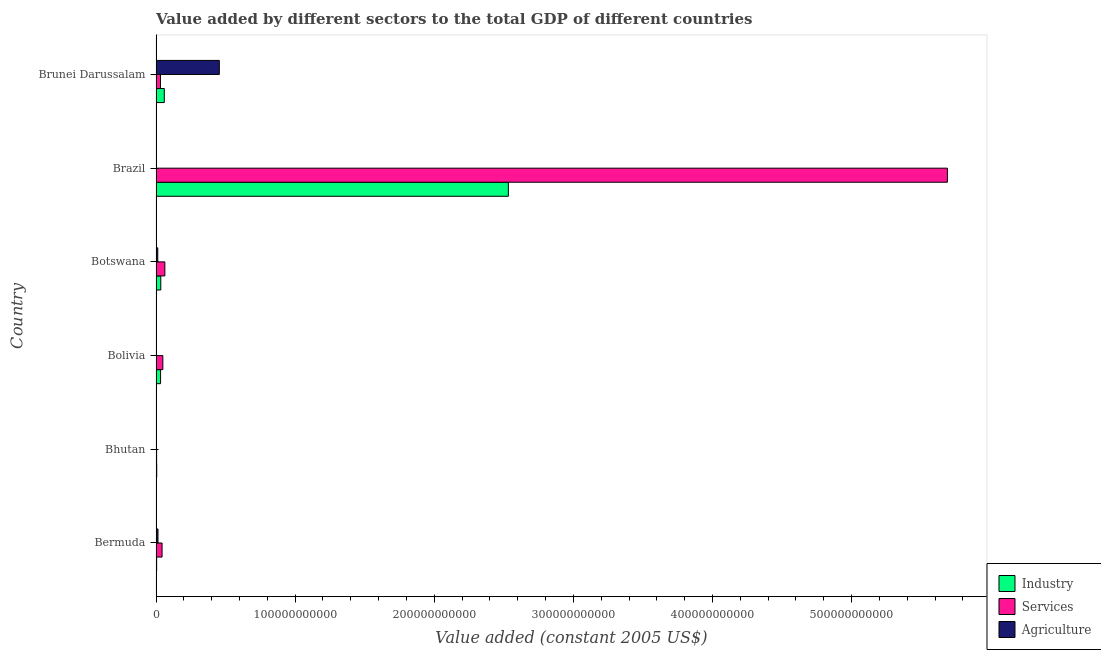Are the number of bars on each tick of the Y-axis equal?
Your answer should be compact. Yes. How many bars are there on the 6th tick from the top?
Offer a terse response. 3. What is the label of the 2nd group of bars from the top?
Your answer should be very brief. Brazil. What is the value added by agricultural sector in Bhutan?
Your answer should be compact. 4.42e+07. Across all countries, what is the maximum value added by industrial sector?
Your response must be concise. 2.53e+11. Across all countries, what is the minimum value added by agricultural sector?
Ensure brevity in your answer.  4.42e+07. In which country was the value added by agricultural sector maximum?
Your response must be concise. Brunei Darussalam. In which country was the value added by agricultural sector minimum?
Your answer should be very brief. Bhutan. What is the total value added by industrial sector in the graph?
Offer a very short reply. 2.67e+11. What is the difference between the value added by services in Bermuda and that in Brunei Darussalam?
Your response must be concise. 1.12e+09. What is the difference between the value added by industrial sector in Bermuda and the value added by agricultural sector in Brunei Darussalam?
Ensure brevity in your answer.  -4.51e+1. What is the average value added by agricultural sector per country?
Your answer should be compact. 8.11e+09. What is the difference between the value added by services and value added by industrial sector in Brunei Darussalam?
Give a very brief answer. -2.73e+09. What is the ratio of the value added by agricultural sector in Bhutan to that in Botswana?
Offer a very short reply. 0.04. What is the difference between the highest and the second highest value added by services?
Provide a succinct answer. 5.63e+11. What is the difference between the highest and the lowest value added by industrial sector?
Ensure brevity in your answer.  2.53e+11. Is the sum of the value added by services in Bhutan and Bolivia greater than the maximum value added by agricultural sector across all countries?
Keep it short and to the point. No. What does the 3rd bar from the top in Bhutan represents?
Provide a succinct answer. Industry. What does the 2nd bar from the bottom in Bolivia represents?
Keep it short and to the point. Services. Is it the case that in every country, the sum of the value added by industrial sector and value added by services is greater than the value added by agricultural sector?
Keep it short and to the point. No. How many countries are there in the graph?
Provide a short and direct response. 6. What is the difference between two consecutive major ticks on the X-axis?
Ensure brevity in your answer.  1.00e+11. Does the graph contain any zero values?
Give a very brief answer. No. Does the graph contain grids?
Ensure brevity in your answer.  No. How many legend labels are there?
Your answer should be very brief. 3. What is the title of the graph?
Make the answer very short. Value added by different sectors to the total GDP of different countries. Does "Domestic" appear as one of the legend labels in the graph?
Provide a succinct answer. No. What is the label or title of the X-axis?
Your answer should be compact. Value added (constant 2005 US$). What is the label or title of the Y-axis?
Your response must be concise. Country. What is the Value added (constant 2005 US$) of Industry in Bermuda?
Ensure brevity in your answer.  4.49e+08. What is the Value added (constant 2005 US$) in Services in Bermuda?
Your response must be concise. 4.35e+09. What is the Value added (constant 2005 US$) in Agriculture in Bermuda?
Your answer should be compact. 1.42e+09. What is the Value added (constant 2005 US$) of Industry in Bhutan?
Keep it short and to the point. 4.95e+08. What is the Value added (constant 2005 US$) in Services in Bhutan?
Your response must be concise. 4.24e+08. What is the Value added (constant 2005 US$) in Agriculture in Bhutan?
Offer a terse response. 4.42e+07. What is the Value added (constant 2005 US$) in Industry in Bolivia?
Give a very brief answer. 3.27e+09. What is the Value added (constant 2005 US$) in Services in Bolivia?
Give a very brief answer. 4.90e+09. What is the Value added (constant 2005 US$) in Agriculture in Bolivia?
Your response must be concise. 1.95e+08. What is the Value added (constant 2005 US$) in Industry in Botswana?
Your response must be concise. 3.42e+09. What is the Value added (constant 2005 US$) in Services in Botswana?
Provide a succinct answer. 6.35e+09. What is the Value added (constant 2005 US$) in Agriculture in Botswana?
Your answer should be compact. 1.24e+09. What is the Value added (constant 2005 US$) in Industry in Brazil?
Give a very brief answer. 2.53e+11. What is the Value added (constant 2005 US$) in Services in Brazil?
Your response must be concise. 5.69e+11. What is the Value added (constant 2005 US$) of Agriculture in Brazil?
Your answer should be compact. 2.51e+08. What is the Value added (constant 2005 US$) in Industry in Brunei Darussalam?
Your answer should be compact. 5.95e+09. What is the Value added (constant 2005 US$) of Services in Brunei Darussalam?
Keep it short and to the point. 3.22e+09. What is the Value added (constant 2005 US$) in Agriculture in Brunei Darussalam?
Your response must be concise. 4.55e+1. Across all countries, what is the maximum Value added (constant 2005 US$) in Industry?
Keep it short and to the point. 2.53e+11. Across all countries, what is the maximum Value added (constant 2005 US$) of Services?
Your answer should be compact. 5.69e+11. Across all countries, what is the maximum Value added (constant 2005 US$) of Agriculture?
Provide a succinct answer. 4.55e+1. Across all countries, what is the minimum Value added (constant 2005 US$) of Industry?
Your answer should be compact. 4.49e+08. Across all countries, what is the minimum Value added (constant 2005 US$) in Services?
Offer a very short reply. 4.24e+08. Across all countries, what is the minimum Value added (constant 2005 US$) of Agriculture?
Your answer should be very brief. 4.42e+07. What is the total Value added (constant 2005 US$) of Industry in the graph?
Offer a terse response. 2.67e+11. What is the total Value added (constant 2005 US$) in Services in the graph?
Give a very brief answer. 5.88e+11. What is the total Value added (constant 2005 US$) of Agriculture in the graph?
Your answer should be compact. 4.87e+1. What is the difference between the Value added (constant 2005 US$) in Industry in Bermuda and that in Bhutan?
Your answer should be very brief. -4.62e+07. What is the difference between the Value added (constant 2005 US$) of Services in Bermuda and that in Bhutan?
Keep it short and to the point. 3.92e+09. What is the difference between the Value added (constant 2005 US$) of Agriculture in Bermuda and that in Bhutan?
Give a very brief answer. 1.37e+09. What is the difference between the Value added (constant 2005 US$) in Industry in Bermuda and that in Bolivia?
Provide a short and direct response. -2.82e+09. What is the difference between the Value added (constant 2005 US$) in Services in Bermuda and that in Bolivia?
Make the answer very short. -5.52e+08. What is the difference between the Value added (constant 2005 US$) of Agriculture in Bermuda and that in Bolivia?
Ensure brevity in your answer.  1.22e+09. What is the difference between the Value added (constant 2005 US$) in Industry in Bermuda and that in Botswana?
Ensure brevity in your answer.  -2.97e+09. What is the difference between the Value added (constant 2005 US$) in Services in Bermuda and that in Botswana?
Give a very brief answer. -2.01e+09. What is the difference between the Value added (constant 2005 US$) in Agriculture in Bermuda and that in Botswana?
Your response must be concise. 1.72e+08. What is the difference between the Value added (constant 2005 US$) of Industry in Bermuda and that in Brazil?
Ensure brevity in your answer.  -2.53e+11. What is the difference between the Value added (constant 2005 US$) of Services in Bermuda and that in Brazil?
Your answer should be very brief. -5.65e+11. What is the difference between the Value added (constant 2005 US$) in Agriculture in Bermuda and that in Brazil?
Your response must be concise. 1.16e+09. What is the difference between the Value added (constant 2005 US$) in Industry in Bermuda and that in Brunei Darussalam?
Offer a terse response. -5.50e+09. What is the difference between the Value added (constant 2005 US$) of Services in Bermuda and that in Brunei Darussalam?
Ensure brevity in your answer.  1.12e+09. What is the difference between the Value added (constant 2005 US$) of Agriculture in Bermuda and that in Brunei Darussalam?
Make the answer very short. -4.41e+1. What is the difference between the Value added (constant 2005 US$) of Industry in Bhutan and that in Bolivia?
Your answer should be compact. -2.77e+09. What is the difference between the Value added (constant 2005 US$) of Services in Bhutan and that in Bolivia?
Offer a terse response. -4.47e+09. What is the difference between the Value added (constant 2005 US$) of Agriculture in Bhutan and that in Bolivia?
Offer a terse response. -1.51e+08. What is the difference between the Value added (constant 2005 US$) of Industry in Bhutan and that in Botswana?
Keep it short and to the point. -2.92e+09. What is the difference between the Value added (constant 2005 US$) in Services in Bhutan and that in Botswana?
Offer a very short reply. -5.93e+09. What is the difference between the Value added (constant 2005 US$) in Agriculture in Bhutan and that in Botswana?
Offer a very short reply. -1.20e+09. What is the difference between the Value added (constant 2005 US$) of Industry in Bhutan and that in Brazil?
Give a very brief answer. -2.53e+11. What is the difference between the Value added (constant 2005 US$) of Services in Bhutan and that in Brazil?
Provide a short and direct response. -5.68e+11. What is the difference between the Value added (constant 2005 US$) in Agriculture in Bhutan and that in Brazil?
Keep it short and to the point. -2.06e+08. What is the difference between the Value added (constant 2005 US$) in Industry in Bhutan and that in Brunei Darussalam?
Your answer should be compact. -5.45e+09. What is the difference between the Value added (constant 2005 US$) in Services in Bhutan and that in Brunei Darussalam?
Ensure brevity in your answer.  -2.80e+09. What is the difference between the Value added (constant 2005 US$) in Agriculture in Bhutan and that in Brunei Darussalam?
Offer a very short reply. -4.55e+1. What is the difference between the Value added (constant 2005 US$) in Industry in Bolivia and that in Botswana?
Provide a short and direct response. -1.52e+08. What is the difference between the Value added (constant 2005 US$) in Services in Bolivia and that in Botswana?
Give a very brief answer. -1.46e+09. What is the difference between the Value added (constant 2005 US$) in Agriculture in Bolivia and that in Botswana?
Your answer should be compact. -1.05e+09. What is the difference between the Value added (constant 2005 US$) in Industry in Bolivia and that in Brazil?
Your answer should be very brief. -2.50e+11. What is the difference between the Value added (constant 2005 US$) of Services in Bolivia and that in Brazil?
Make the answer very short. -5.64e+11. What is the difference between the Value added (constant 2005 US$) of Agriculture in Bolivia and that in Brazil?
Give a very brief answer. -5.51e+07. What is the difference between the Value added (constant 2005 US$) of Industry in Bolivia and that in Brunei Darussalam?
Make the answer very short. -2.68e+09. What is the difference between the Value added (constant 2005 US$) in Services in Bolivia and that in Brunei Darussalam?
Make the answer very short. 1.68e+09. What is the difference between the Value added (constant 2005 US$) of Agriculture in Bolivia and that in Brunei Darussalam?
Provide a succinct answer. -4.53e+1. What is the difference between the Value added (constant 2005 US$) in Industry in Botswana and that in Brazil?
Provide a succinct answer. -2.50e+11. What is the difference between the Value added (constant 2005 US$) of Services in Botswana and that in Brazil?
Your response must be concise. -5.63e+11. What is the difference between the Value added (constant 2005 US$) in Agriculture in Botswana and that in Brazil?
Offer a very short reply. 9.92e+08. What is the difference between the Value added (constant 2005 US$) of Industry in Botswana and that in Brunei Darussalam?
Offer a terse response. -2.53e+09. What is the difference between the Value added (constant 2005 US$) of Services in Botswana and that in Brunei Darussalam?
Your response must be concise. 3.13e+09. What is the difference between the Value added (constant 2005 US$) in Agriculture in Botswana and that in Brunei Darussalam?
Your response must be concise. -4.43e+1. What is the difference between the Value added (constant 2005 US$) of Industry in Brazil and that in Brunei Darussalam?
Keep it short and to the point. 2.47e+11. What is the difference between the Value added (constant 2005 US$) in Services in Brazil and that in Brunei Darussalam?
Your response must be concise. 5.66e+11. What is the difference between the Value added (constant 2005 US$) of Agriculture in Brazil and that in Brunei Darussalam?
Make the answer very short. -4.53e+1. What is the difference between the Value added (constant 2005 US$) of Industry in Bermuda and the Value added (constant 2005 US$) of Services in Bhutan?
Provide a succinct answer. 2.50e+07. What is the difference between the Value added (constant 2005 US$) in Industry in Bermuda and the Value added (constant 2005 US$) in Agriculture in Bhutan?
Provide a succinct answer. 4.05e+08. What is the difference between the Value added (constant 2005 US$) of Services in Bermuda and the Value added (constant 2005 US$) of Agriculture in Bhutan?
Keep it short and to the point. 4.30e+09. What is the difference between the Value added (constant 2005 US$) in Industry in Bermuda and the Value added (constant 2005 US$) in Services in Bolivia?
Ensure brevity in your answer.  -4.45e+09. What is the difference between the Value added (constant 2005 US$) of Industry in Bermuda and the Value added (constant 2005 US$) of Agriculture in Bolivia?
Offer a very short reply. 2.54e+08. What is the difference between the Value added (constant 2005 US$) of Services in Bermuda and the Value added (constant 2005 US$) of Agriculture in Bolivia?
Offer a very short reply. 4.15e+09. What is the difference between the Value added (constant 2005 US$) of Industry in Bermuda and the Value added (constant 2005 US$) of Services in Botswana?
Your answer should be compact. -5.90e+09. What is the difference between the Value added (constant 2005 US$) of Industry in Bermuda and the Value added (constant 2005 US$) of Agriculture in Botswana?
Your answer should be compact. -7.94e+08. What is the difference between the Value added (constant 2005 US$) in Services in Bermuda and the Value added (constant 2005 US$) in Agriculture in Botswana?
Your response must be concise. 3.10e+09. What is the difference between the Value added (constant 2005 US$) in Industry in Bermuda and the Value added (constant 2005 US$) in Services in Brazil?
Your answer should be compact. -5.68e+11. What is the difference between the Value added (constant 2005 US$) of Industry in Bermuda and the Value added (constant 2005 US$) of Agriculture in Brazil?
Offer a very short reply. 1.99e+08. What is the difference between the Value added (constant 2005 US$) in Services in Bermuda and the Value added (constant 2005 US$) in Agriculture in Brazil?
Provide a short and direct response. 4.10e+09. What is the difference between the Value added (constant 2005 US$) in Industry in Bermuda and the Value added (constant 2005 US$) in Services in Brunei Darussalam?
Offer a terse response. -2.77e+09. What is the difference between the Value added (constant 2005 US$) of Industry in Bermuda and the Value added (constant 2005 US$) of Agriculture in Brunei Darussalam?
Offer a terse response. -4.51e+1. What is the difference between the Value added (constant 2005 US$) in Services in Bermuda and the Value added (constant 2005 US$) in Agriculture in Brunei Darussalam?
Give a very brief answer. -4.12e+1. What is the difference between the Value added (constant 2005 US$) of Industry in Bhutan and the Value added (constant 2005 US$) of Services in Bolivia?
Ensure brevity in your answer.  -4.40e+09. What is the difference between the Value added (constant 2005 US$) of Industry in Bhutan and the Value added (constant 2005 US$) of Agriculture in Bolivia?
Your answer should be very brief. 3.00e+08. What is the difference between the Value added (constant 2005 US$) in Services in Bhutan and the Value added (constant 2005 US$) in Agriculture in Bolivia?
Make the answer very short. 2.29e+08. What is the difference between the Value added (constant 2005 US$) of Industry in Bhutan and the Value added (constant 2005 US$) of Services in Botswana?
Your answer should be very brief. -5.86e+09. What is the difference between the Value added (constant 2005 US$) of Industry in Bhutan and the Value added (constant 2005 US$) of Agriculture in Botswana?
Offer a very short reply. -7.47e+08. What is the difference between the Value added (constant 2005 US$) of Services in Bhutan and the Value added (constant 2005 US$) of Agriculture in Botswana?
Keep it short and to the point. -8.19e+08. What is the difference between the Value added (constant 2005 US$) of Industry in Bhutan and the Value added (constant 2005 US$) of Services in Brazil?
Make the answer very short. -5.68e+11. What is the difference between the Value added (constant 2005 US$) in Industry in Bhutan and the Value added (constant 2005 US$) in Agriculture in Brazil?
Your answer should be very brief. 2.45e+08. What is the difference between the Value added (constant 2005 US$) in Services in Bhutan and the Value added (constant 2005 US$) in Agriculture in Brazil?
Your answer should be compact. 1.74e+08. What is the difference between the Value added (constant 2005 US$) of Industry in Bhutan and the Value added (constant 2005 US$) of Services in Brunei Darussalam?
Keep it short and to the point. -2.73e+09. What is the difference between the Value added (constant 2005 US$) in Industry in Bhutan and the Value added (constant 2005 US$) in Agriculture in Brunei Darussalam?
Keep it short and to the point. -4.50e+1. What is the difference between the Value added (constant 2005 US$) of Services in Bhutan and the Value added (constant 2005 US$) of Agriculture in Brunei Darussalam?
Keep it short and to the point. -4.51e+1. What is the difference between the Value added (constant 2005 US$) of Industry in Bolivia and the Value added (constant 2005 US$) of Services in Botswana?
Offer a terse response. -3.09e+09. What is the difference between the Value added (constant 2005 US$) in Industry in Bolivia and the Value added (constant 2005 US$) in Agriculture in Botswana?
Give a very brief answer. 2.02e+09. What is the difference between the Value added (constant 2005 US$) in Services in Bolivia and the Value added (constant 2005 US$) in Agriculture in Botswana?
Provide a short and direct response. 3.66e+09. What is the difference between the Value added (constant 2005 US$) of Industry in Bolivia and the Value added (constant 2005 US$) of Services in Brazil?
Offer a very short reply. -5.66e+11. What is the difference between the Value added (constant 2005 US$) in Industry in Bolivia and the Value added (constant 2005 US$) in Agriculture in Brazil?
Make the answer very short. 3.02e+09. What is the difference between the Value added (constant 2005 US$) of Services in Bolivia and the Value added (constant 2005 US$) of Agriculture in Brazil?
Keep it short and to the point. 4.65e+09. What is the difference between the Value added (constant 2005 US$) in Industry in Bolivia and the Value added (constant 2005 US$) in Services in Brunei Darussalam?
Your response must be concise. 4.39e+07. What is the difference between the Value added (constant 2005 US$) of Industry in Bolivia and the Value added (constant 2005 US$) of Agriculture in Brunei Darussalam?
Provide a succinct answer. -4.22e+1. What is the difference between the Value added (constant 2005 US$) of Services in Bolivia and the Value added (constant 2005 US$) of Agriculture in Brunei Darussalam?
Your answer should be compact. -4.06e+1. What is the difference between the Value added (constant 2005 US$) of Industry in Botswana and the Value added (constant 2005 US$) of Services in Brazil?
Give a very brief answer. -5.65e+11. What is the difference between the Value added (constant 2005 US$) in Industry in Botswana and the Value added (constant 2005 US$) in Agriculture in Brazil?
Keep it short and to the point. 3.17e+09. What is the difference between the Value added (constant 2005 US$) of Services in Botswana and the Value added (constant 2005 US$) of Agriculture in Brazil?
Make the answer very short. 6.10e+09. What is the difference between the Value added (constant 2005 US$) in Industry in Botswana and the Value added (constant 2005 US$) in Services in Brunei Darussalam?
Keep it short and to the point. 1.96e+08. What is the difference between the Value added (constant 2005 US$) in Industry in Botswana and the Value added (constant 2005 US$) in Agriculture in Brunei Darussalam?
Your answer should be compact. -4.21e+1. What is the difference between the Value added (constant 2005 US$) of Services in Botswana and the Value added (constant 2005 US$) of Agriculture in Brunei Darussalam?
Ensure brevity in your answer.  -3.92e+1. What is the difference between the Value added (constant 2005 US$) in Industry in Brazil and the Value added (constant 2005 US$) in Services in Brunei Darussalam?
Your answer should be very brief. 2.50e+11. What is the difference between the Value added (constant 2005 US$) in Industry in Brazil and the Value added (constant 2005 US$) in Agriculture in Brunei Darussalam?
Your answer should be very brief. 2.08e+11. What is the difference between the Value added (constant 2005 US$) in Services in Brazil and the Value added (constant 2005 US$) in Agriculture in Brunei Darussalam?
Give a very brief answer. 5.23e+11. What is the average Value added (constant 2005 US$) in Industry per country?
Keep it short and to the point. 4.45e+1. What is the average Value added (constant 2005 US$) in Services per country?
Offer a terse response. 9.80e+1. What is the average Value added (constant 2005 US$) of Agriculture per country?
Offer a terse response. 8.11e+09. What is the difference between the Value added (constant 2005 US$) in Industry and Value added (constant 2005 US$) in Services in Bermuda?
Offer a terse response. -3.90e+09. What is the difference between the Value added (constant 2005 US$) in Industry and Value added (constant 2005 US$) in Agriculture in Bermuda?
Keep it short and to the point. -9.66e+08. What is the difference between the Value added (constant 2005 US$) in Services and Value added (constant 2005 US$) in Agriculture in Bermuda?
Provide a short and direct response. 2.93e+09. What is the difference between the Value added (constant 2005 US$) in Industry and Value added (constant 2005 US$) in Services in Bhutan?
Your answer should be very brief. 7.12e+07. What is the difference between the Value added (constant 2005 US$) in Industry and Value added (constant 2005 US$) in Agriculture in Bhutan?
Your answer should be very brief. 4.51e+08. What is the difference between the Value added (constant 2005 US$) in Services and Value added (constant 2005 US$) in Agriculture in Bhutan?
Keep it short and to the point. 3.80e+08. What is the difference between the Value added (constant 2005 US$) in Industry and Value added (constant 2005 US$) in Services in Bolivia?
Keep it short and to the point. -1.63e+09. What is the difference between the Value added (constant 2005 US$) in Industry and Value added (constant 2005 US$) in Agriculture in Bolivia?
Keep it short and to the point. 3.07e+09. What is the difference between the Value added (constant 2005 US$) of Services and Value added (constant 2005 US$) of Agriculture in Bolivia?
Keep it short and to the point. 4.70e+09. What is the difference between the Value added (constant 2005 US$) in Industry and Value added (constant 2005 US$) in Services in Botswana?
Your response must be concise. -2.94e+09. What is the difference between the Value added (constant 2005 US$) in Industry and Value added (constant 2005 US$) in Agriculture in Botswana?
Provide a succinct answer. 2.18e+09. What is the difference between the Value added (constant 2005 US$) in Services and Value added (constant 2005 US$) in Agriculture in Botswana?
Provide a succinct answer. 5.11e+09. What is the difference between the Value added (constant 2005 US$) in Industry and Value added (constant 2005 US$) in Services in Brazil?
Ensure brevity in your answer.  -3.16e+11. What is the difference between the Value added (constant 2005 US$) of Industry and Value added (constant 2005 US$) of Agriculture in Brazil?
Ensure brevity in your answer.  2.53e+11. What is the difference between the Value added (constant 2005 US$) of Services and Value added (constant 2005 US$) of Agriculture in Brazil?
Your answer should be compact. 5.69e+11. What is the difference between the Value added (constant 2005 US$) in Industry and Value added (constant 2005 US$) in Services in Brunei Darussalam?
Provide a short and direct response. 2.73e+09. What is the difference between the Value added (constant 2005 US$) of Industry and Value added (constant 2005 US$) of Agriculture in Brunei Darussalam?
Offer a terse response. -3.96e+1. What is the difference between the Value added (constant 2005 US$) in Services and Value added (constant 2005 US$) in Agriculture in Brunei Darussalam?
Keep it short and to the point. -4.23e+1. What is the ratio of the Value added (constant 2005 US$) in Industry in Bermuda to that in Bhutan?
Your response must be concise. 0.91. What is the ratio of the Value added (constant 2005 US$) of Services in Bermuda to that in Bhutan?
Make the answer very short. 10.25. What is the ratio of the Value added (constant 2005 US$) in Agriculture in Bermuda to that in Bhutan?
Keep it short and to the point. 31.99. What is the ratio of the Value added (constant 2005 US$) of Industry in Bermuda to that in Bolivia?
Your answer should be very brief. 0.14. What is the ratio of the Value added (constant 2005 US$) in Services in Bermuda to that in Bolivia?
Ensure brevity in your answer.  0.89. What is the ratio of the Value added (constant 2005 US$) of Agriculture in Bermuda to that in Bolivia?
Keep it short and to the point. 7.24. What is the ratio of the Value added (constant 2005 US$) in Industry in Bermuda to that in Botswana?
Keep it short and to the point. 0.13. What is the ratio of the Value added (constant 2005 US$) of Services in Bermuda to that in Botswana?
Make the answer very short. 0.68. What is the ratio of the Value added (constant 2005 US$) of Agriculture in Bermuda to that in Botswana?
Your answer should be very brief. 1.14. What is the ratio of the Value added (constant 2005 US$) of Industry in Bermuda to that in Brazil?
Keep it short and to the point. 0. What is the ratio of the Value added (constant 2005 US$) of Services in Bermuda to that in Brazil?
Provide a short and direct response. 0.01. What is the ratio of the Value added (constant 2005 US$) in Agriculture in Bermuda to that in Brazil?
Your answer should be compact. 5.65. What is the ratio of the Value added (constant 2005 US$) in Industry in Bermuda to that in Brunei Darussalam?
Your answer should be very brief. 0.08. What is the ratio of the Value added (constant 2005 US$) in Services in Bermuda to that in Brunei Darussalam?
Keep it short and to the point. 1.35. What is the ratio of the Value added (constant 2005 US$) in Agriculture in Bermuda to that in Brunei Darussalam?
Offer a terse response. 0.03. What is the ratio of the Value added (constant 2005 US$) in Industry in Bhutan to that in Bolivia?
Provide a short and direct response. 0.15. What is the ratio of the Value added (constant 2005 US$) of Services in Bhutan to that in Bolivia?
Your response must be concise. 0.09. What is the ratio of the Value added (constant 2005 US$) of Agriculture in Bhutan to that in Bolivia?
Provide a short and direct response. 0.23. What is the ratio of the Value added (constant 2005 US$) of Industry in Bhutan to that in Botswana?
Ensure brevity in your answer.  0.14. What is the ratio of the Value added (constant 2005 US$) of Services in Bhutan to that in Botswana?
Offer a terse response. 0.07. What is the ratio of the Value added (constant 2005 US$) in Agriculture in Bhutan to that in Botswana?
Your response must be concise. 0.04. What is the ratio of the Value added (constant 2005 US$) of Industry in Bhutan to that in Brazil?
Make the answer very short. 0. What is the ratio of the Value added (constant 2005 US$) in Services in Bhutan to that in Brazil?
Make the answer very short. 0. What is the ratio of the Value added (constant 2005 US$) of Agriculture in Bhutan to that in Brazil?
Offer a very short reply. 0.18. What is the ratio of the Value added (constant 2005 US$) of Industry in Bhutan to that in Brunei Darussalam?
Provide a short and direct response. 0.08. What is the ratio of the Value added (constant 2005 US$) in Services in Bhutan to that in Brunei Darussalam?
Ensure brevity in your answer.  0.13. What is the ratio of the Value added (constant 2005 US$) in Industry in Bolivia to that in Botswana?
Make the answer very short. 0.96. What is the ratio of the Value added (constant 2005 US$) of Services in Bolivia to that in Botswana?
Make the answer very short. 0.77. What is the ratio of the Value added (constant 2005 US$) in Agriculture in Bolivia to that in Botswana?
Your answer should be very brief. 0.16. What is the ratio of the Value added (constant 2005 US$) in Industry in Bolivia to that in Brazil?
Your answer should be compact. 0.01. What is the ratio of the Value added (constant 2005 US$) in Services in Bolivia to that in Brazil?
Ensure brevity in your answer.  0.01. What is the ratio of the Value added (constant 2005 US$) of Agriculture in Bolivia to that in Brazil?
Provide a succinct answer. 0.78. What is the ratio of the Value added (constant 2005 US$) in Industry in Bolivia to that in Brunei Darussalam?
Provide a short and direct response. 0.55. What is the ratio of the Value added (constant 2005 US$) in Services in Bolivia to that in Brunei Darussalam?
Offer a very short reply. 1.52. What is the ratio of the Value added (constant 2005 US$) of Agriculture in Bolivia to that in Brunei Darussalam?
Ensure brevity in your answer.  0. What is the ratio of the Value added (constant 2005 US$) of Industry in Botswana to that in Brazil?
Offer a very short reply. 0.01. What is the ratio of the Value added (constant 2005 US$) in Services in Botswana to that in Brazil?
Keep it short and to the point. 0.01. What is the ratio of the Value added (constant 2005 US$) in Agriculture in Botswana to that in Brazil?
Make the answer very short. 4.96. What is the ratio of the Value added (constant 2005 US$) of Industry in Botswana to that in Brunei Darussalam?
Your answer should be compact. 0.57. What is the ratio of the Value added (constant 2005 US$) of Services in Botswana to that in Brunei Darussalam?
Ensure brevity in your answer.  1.97. What is the ratio of the Value added (constant 2005 US$) in Agriculture in Botswana to that in Brunei Darussalam?
Your answer should be very brief. 0.03. What is the ratio of the Value added (constant 2005 US$) in Industry in Brazil to that in Brunei Darussalam?
Give a very brief answer. 42.57. What is the ratio of the Value added (constant 2005 US$) of Services in Brazil to that in Brunei Darussalam?
Offer a very short reply. 176.58. What is the ratio of the Value added (constant 2005 US$) in Agriculture in Brazil to that in Brunei Darussalam?
Your response must be concise. 0.01. What is the difference between the highest and the second highest Value added (constant 2005 US$) of Industry?
Your answer should be compact. 2.47e+11. What is the difference between the highest and the second highest Value added (constant 2005 US$) of Services?
Your response must be concise. 5.63e+11. What is the difference between the highest and the second highest Value added (constant 2005 US$) in Agriculture?
Ensure brevity in your answer.  4.41e+1. What is the difference between the highest and the lowest Value added (constant 2005 US$) in Industry?
Give a very brief answer. 2.53e+11. What is the difference between the highest and the lowest Value added (constant 2005 US$) in Services?
Provide a short and direct response. 5.68e+11. What is the difference between the highest and the lowest Value added (constant 2005 US$) of Agriculture?
Provide a short and direct response. 4.55e+1. 